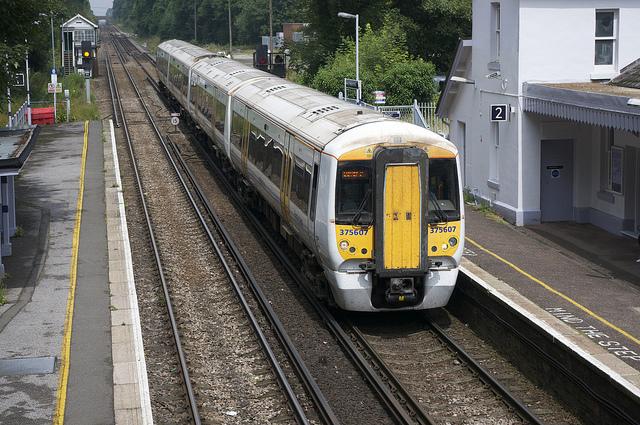Why is there a yellow line on the loading platforms?
Answer briefly. Safety. What color shows on the stoplight?
Give a very brief answer. Yellow. What number is on the building?
Give a very brief answer. 2. How many sets of tracks are there?
Keep it brief. 2. 